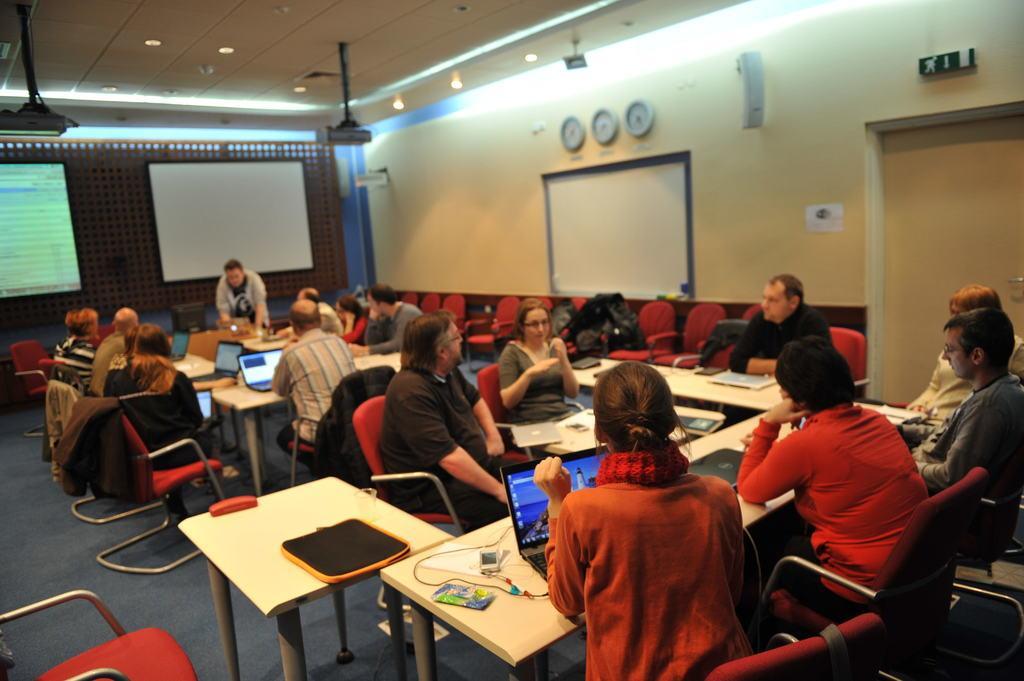Can you describe this image briefly? In this image few people are sitting on chairs and person at the middle is standing. Person at the bottom of the image is having laptop before her on the table which is having wire and some packet on it. There are three clocks fixed to the wall and two screens are attached to the wall. There are two projectors hanged to the roof. There is a door at the right side of image. 